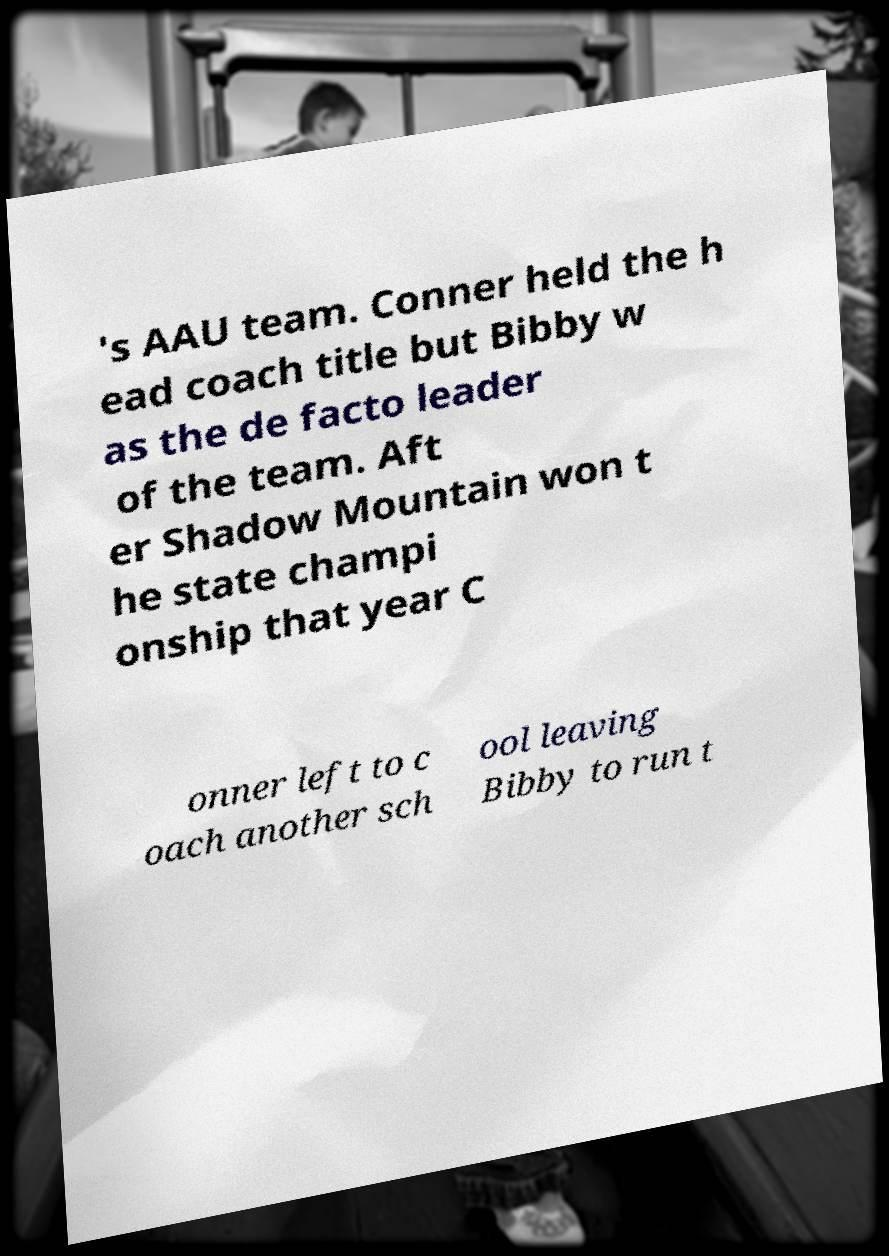Please identify and transcribe the text found in this image. 's AAU team. Conner held the h ead coach title but Bibby w as the de facto leader of the team. Aft er Shadow Mountain won t he state champi onship that year C onner left to c oach another sch ool leaving Bibby to run t 